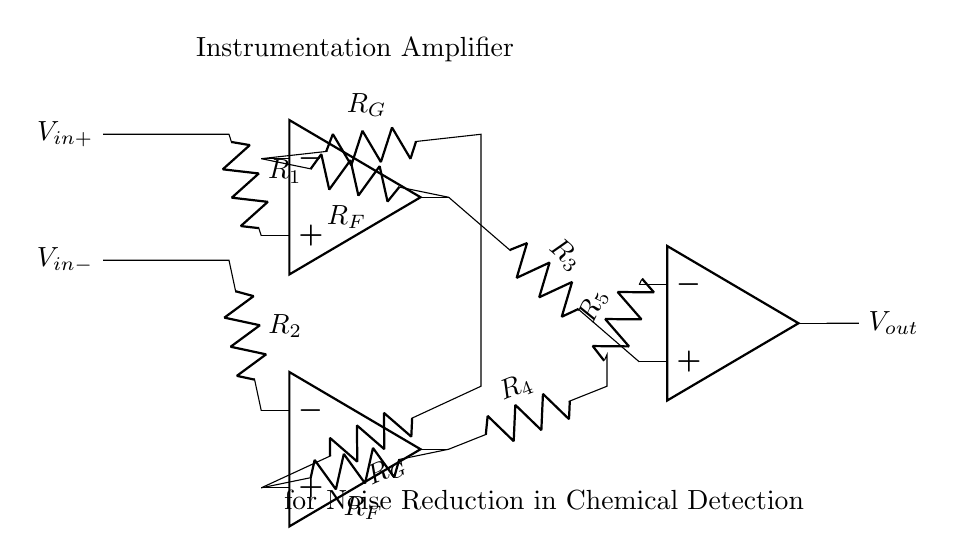What type of amplifier is shown in the circuit? The circuit represents an instrumentation amplifier, as it has multiple operational amplifiers configured to amplify the difference between two input signals while rejecting common-mode noise.
Answer: instrumentation amplifier How many operational amplifiers are used in the circuit? There are three operational amplifiers depicted in the circuit diagram, each serving to process the input signals in conjunction with feedback and gain settings.
Answer: three What is the function of the resistors labeled R1 and R2? R1 and R2 are input resistors that establish the initial differential voltage by connecting the input signals to the operational amplifiers. They play a crucial role in setting the gain and determining how the inputs interact.
Answer: establish differential voltage What is the purpose of the feedback resistors R_G? R_G is a feedback resistor that is used in the configuration to set the gain of the instrumentation amplifier, which will impact the sensitivity and response of the circuit to small changes in the input voltages.
Answer: set gain How do the resistors R_F influence the output signal? R_F works as feedback resistors which define the closed-loop gain of each operational amplifier. By affecting the feedback loop, they help control the amplification level of the output signal relative to the input differential voltage.
Answer: control amplification What is the role of the output op-amp in this circuit? The output operational amplifier (opa3) is responsible for summing the amplified outputs from the input op-amps and providing a single output voltage that reflects the amplified difference between the input signals.
Answer: amplify output difference What result would an increase in R_G have on the output signal? Increasing R_G typically decreases the overall gain of the instrumentation amplifier, which means the output signal would be less sensitive to variations in the input signals, leading to a reduced response to small changes.
Answer: decrease gain 